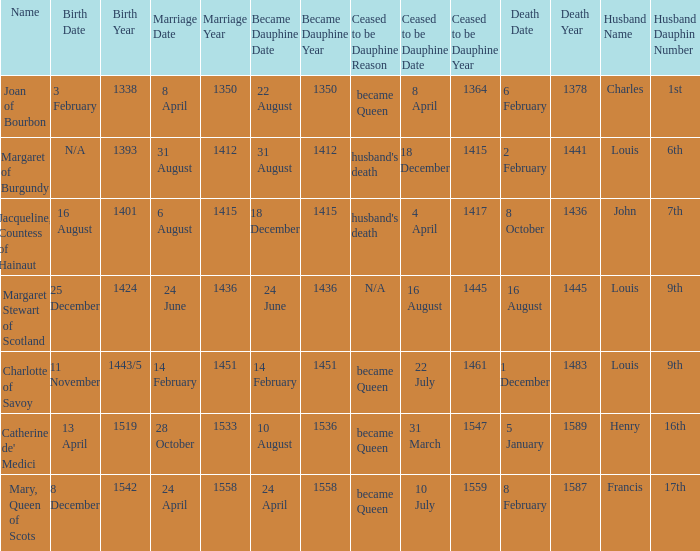Who has a birth of 16 august 1401? Jacqueline, Countess of Hainaut. 